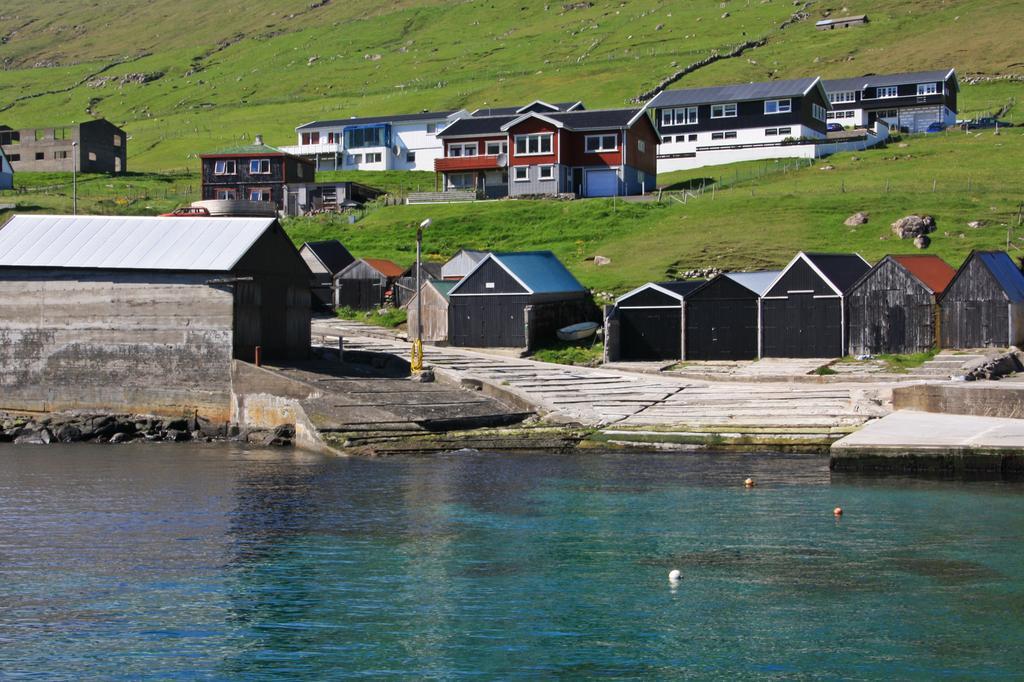Please provide a concise description of this image. In this image I can see buildings, poles, the grass and some other objects on the ground. Here I can see the water. 